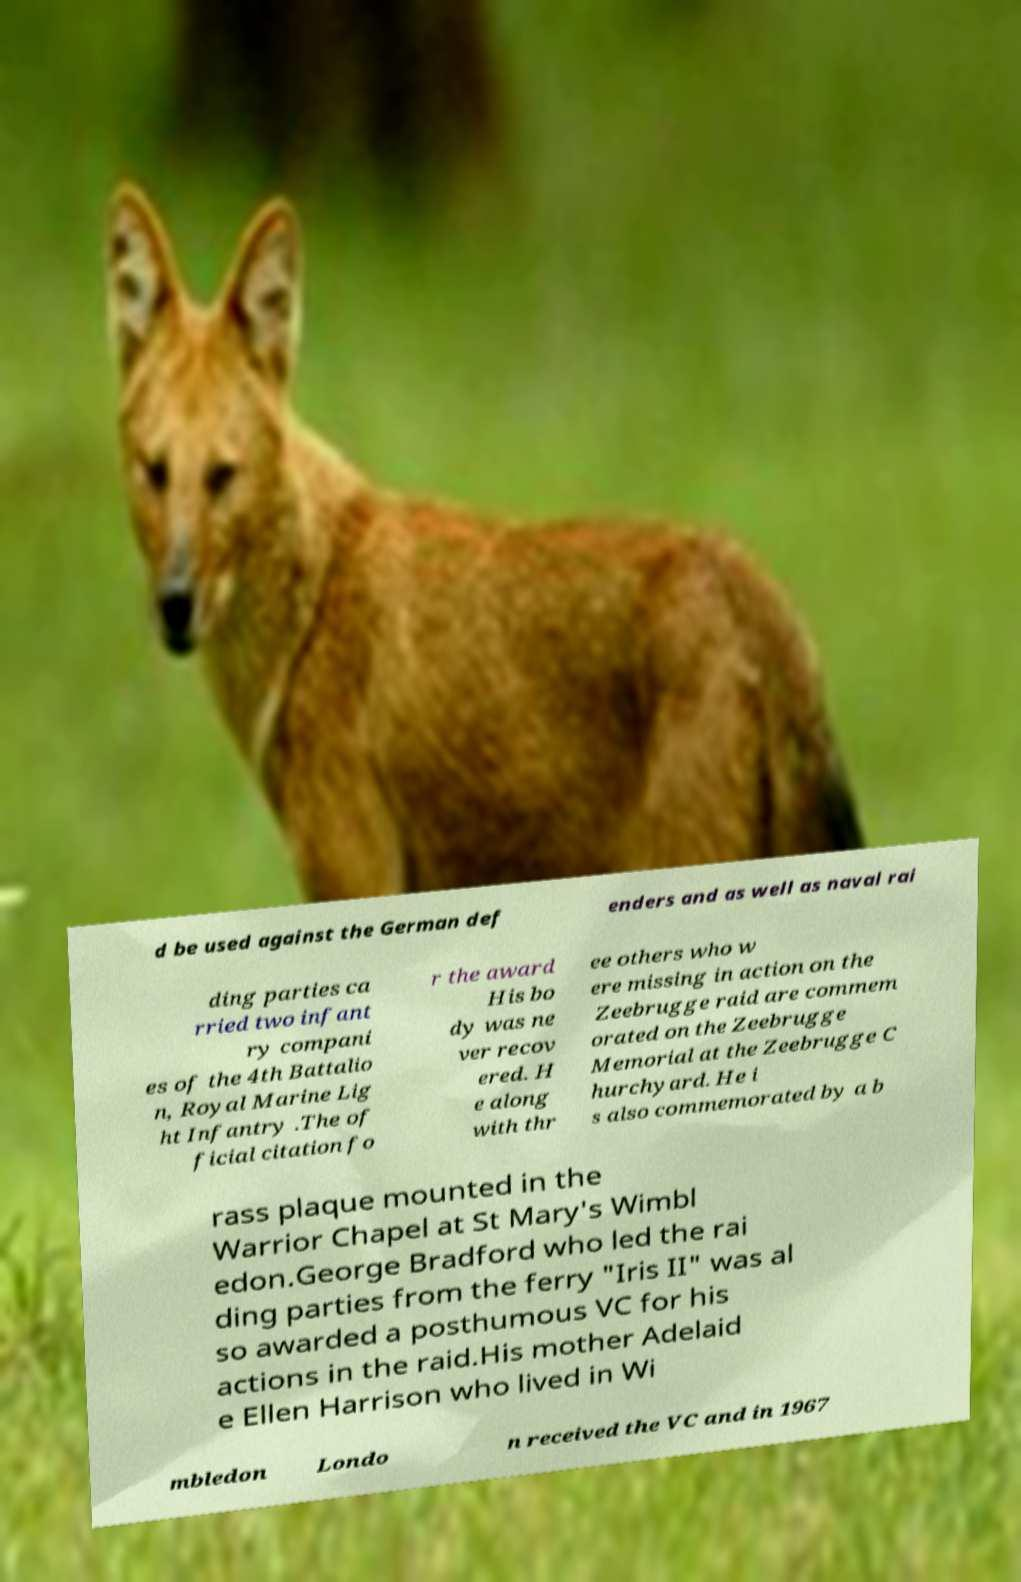There's text embedded in this image that I need extracted. Can you transcribe it verbatim? d be used against the German def enders and as well as naval rai ding parties ca rried two infant ry compani es of the 4th Battalio n, Royal Marine Lig ht Infantry .The of ficial citation fo r the award His bo dy was ne ver recov ered. H e along with thr ee others who w ere missing in action on the Zeebrugge raid are commem orated on the Zeebrugge Memorial at the Zeebrugge C hurchyard. He i s also commemorated by a b rass plaque mounted in the Warrior Chapel at St Mary's Wimbl edon.George Bradford who led the rai ding parties from the ferry "Iris II" was al so awarded a posthumous VC for his actions in the raid.His mother Adelaid e Ellen Harrison who lived in Wi mbledon Londo n received the VC and in 1967 